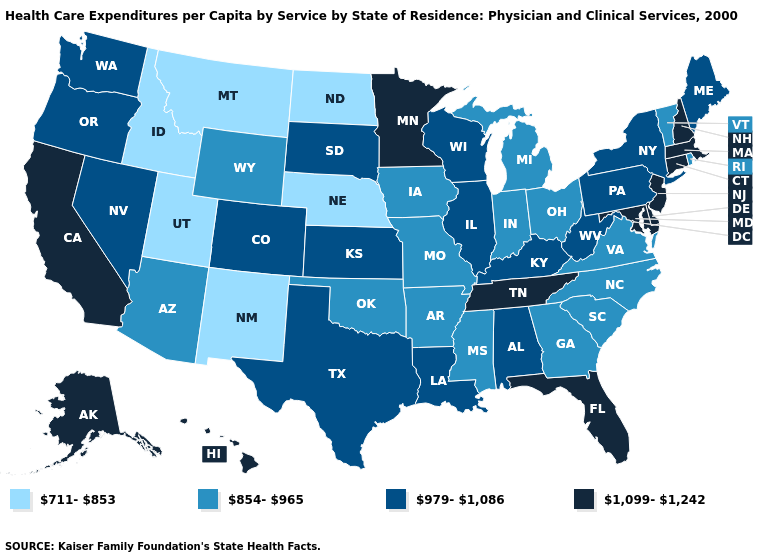What is the lowest value in the Northeast?
Concise answer only. 854-965. Name the states that have a value in the range 1,099-1,242?
Give a very brief answer. Alaska, California, Connecticut, Delaware, Florida, Hawaii, Maryland, Massachusetts, Minnesota, New Hampshire, New Jersey, Tennessee. What is the lowest value in the South?
Give a very brief answer. 854-965. What is the value of Kansas?
Answer briefly. 979-1,086. What is the lowest value in the Northeast?
Short answer required. 854-965. Which states have the lowest value in the MidWest?
Concise answer only. Nebraska, North Dakota. Name the states that have a value in the range 1,099-1,242?
Concise answer only. Alaska, California, Connecticut, Delaware, Florida, Hawaii, Maryland, Massachusetts, Minnesota, New Hampshire, New Jersey, Tennessee. What is the lowest value in the USA?
Short answer required. 711-853. Name the states that have a value in the range 854-965?
Keep it brief. Arizona, Arkansas, Georgia, Indiana, Iowa, Michigan, Mississippi, Missouri, North Carolina, Ohio, Oklahoma, Rhode Island, South Carolina, Vermont, Virginia, Wyoming. What is the value of Florida?
Give a very brief answer. 1,099-1,242. Does the map have missing data?
Short answer required. No. What is the value of Wyoming?
Be succinct. 854-965. Name the states that have a value in the range 1,099-1,242?
Keep it brief. Alaska, California, Connecticut, Delaware, Florida, Hawaii, Maryland, Massachusetts, Minnesota, New Hampshire, New Jersey, Tennessee. What is the highest value in the South ?
Quick response, please. 1,099-1,242. 